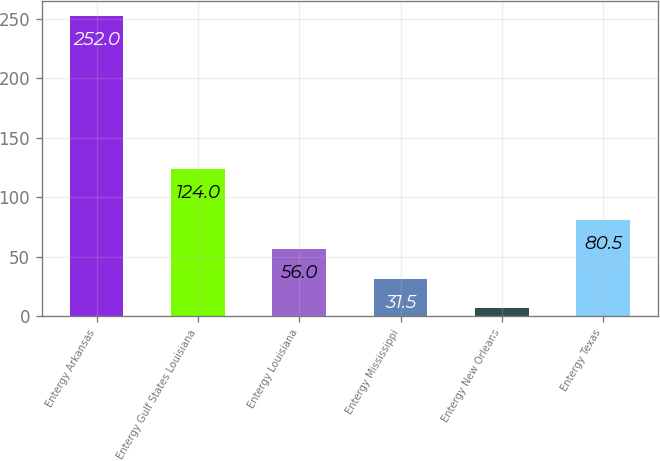Convert chart to OTSL. <chart><loc_0><loc_0><loc_500><loc_500><bar_chart><fcel>Entergy Arkansas<fcel>Entergy Gulf States Louisiana<fcel>Entergy Louisiana<fcel>Entergy Mississippi<fcel>Entergy New Orleans<fcel>Entergy Texas<nl><fcel>252<fcel>124<fcel>56<fcel>31.5<fcel>7<fcel>80.5<nl></chart> 